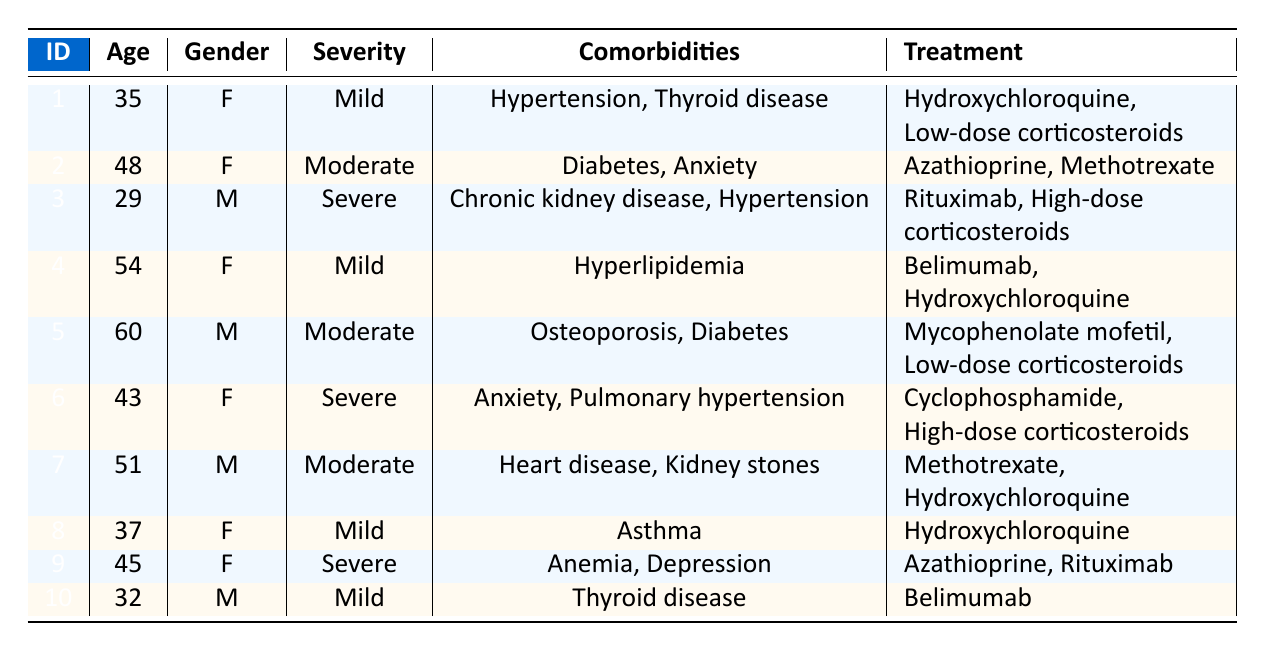What are the comorbidities listed for patient 3? Patient 3 has chronic kidney disease and hypertension as comorbidities, which are explicitly stated in the table.
Answer: Chronic kidney disease, hypertension How many patients have diabetes listed as a comorbidity? By reviewing the table, diabetes appears in the comorbidities of patient 2 and patient 5. Therefore, there are 2 patients with diabetes.
Answer: 2 Is there any male patient with severe lupus? Looking through the table, patient 3 and patient 6 are males, but only patient 3 is listed with severe lupus. Therefore, the answer is yes.
Answer: Yes What is the average age of patients with mild lupus severity? The ages of the patients with mild lupus severity are 35 (patient 1), 54 (patient 4), and 32 (patient 10). Summing these ages gives: 35 + 54 + 32 = 121. There are 3 patients, so the average age is 121/3 = 40.33.
Answer: 40.33 Which comorbidity appears most frequently among the patients? By checking the comorbidities, we see that diabetes appears in patients 2 and 5, hypertension appears in patients 1 and 3, anxiety appears in patients 2 and 6, but the comorbidities with the highest frequency are diabetes and hypertension, both appearing twice each.
Answer: Diabetes and hypertension (both appear twice) 